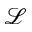Convert formula to latex. <formula><loc_0><loc_0><loc_500><loc_500>\mathcal { L }</formula> 